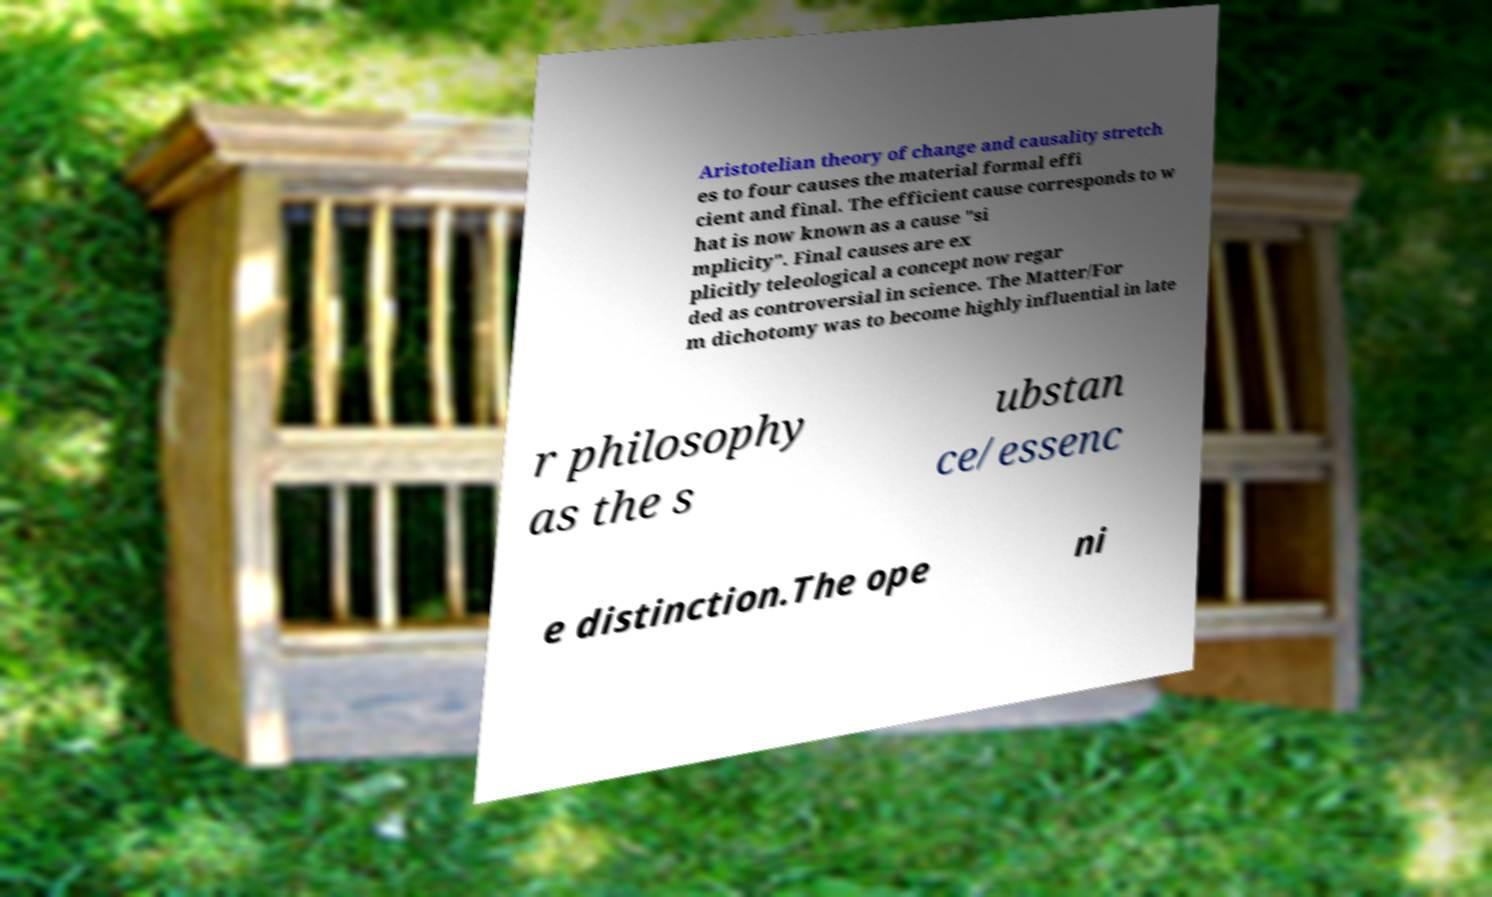What messages or text are displayed in this image? I need them in a readable, typed format. Aristotelian theory of change and causality stretch es to four causes the material formal effi cient and final. The efficient cause corresponds to w hat is now known as a cause "si mplicity". Final causes are ex plicitly teleological a concept now regar ded as controversial in science. The Matter/For m dichotomy was to become highly influential in late r philosophy as the s ubstan ce/essenc e distinction.The ope ni 